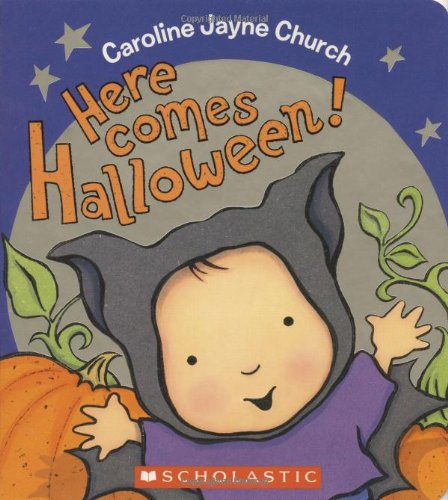Who is the author of this book? The author of the book shown in the image is Caroline Jayne Church, a renowned writer and illustrator famous for her captivating children's books. 